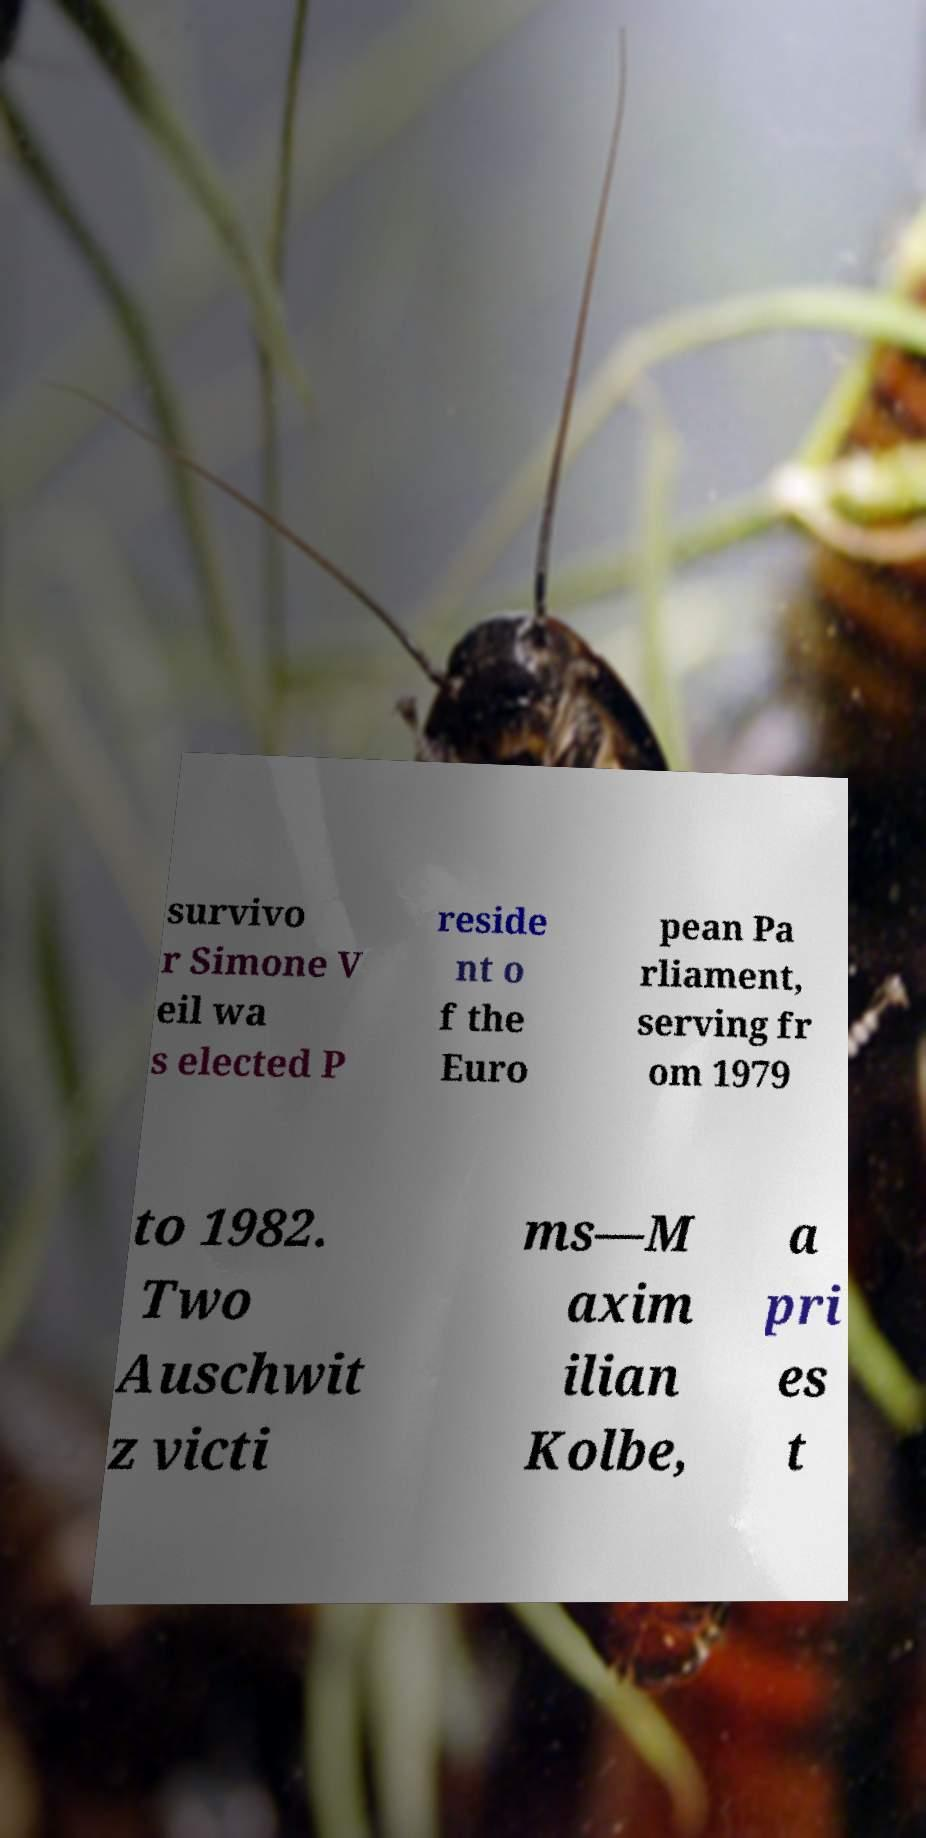Could you extract and type out the text from this image? survivo r Simone V eil wa s elected P reside nt o f the Euro pean Pa rliament, serving fr om 1979 to 1982. Two Auschwit z victi ms—M axim ilian Kolbe, a pri es t 